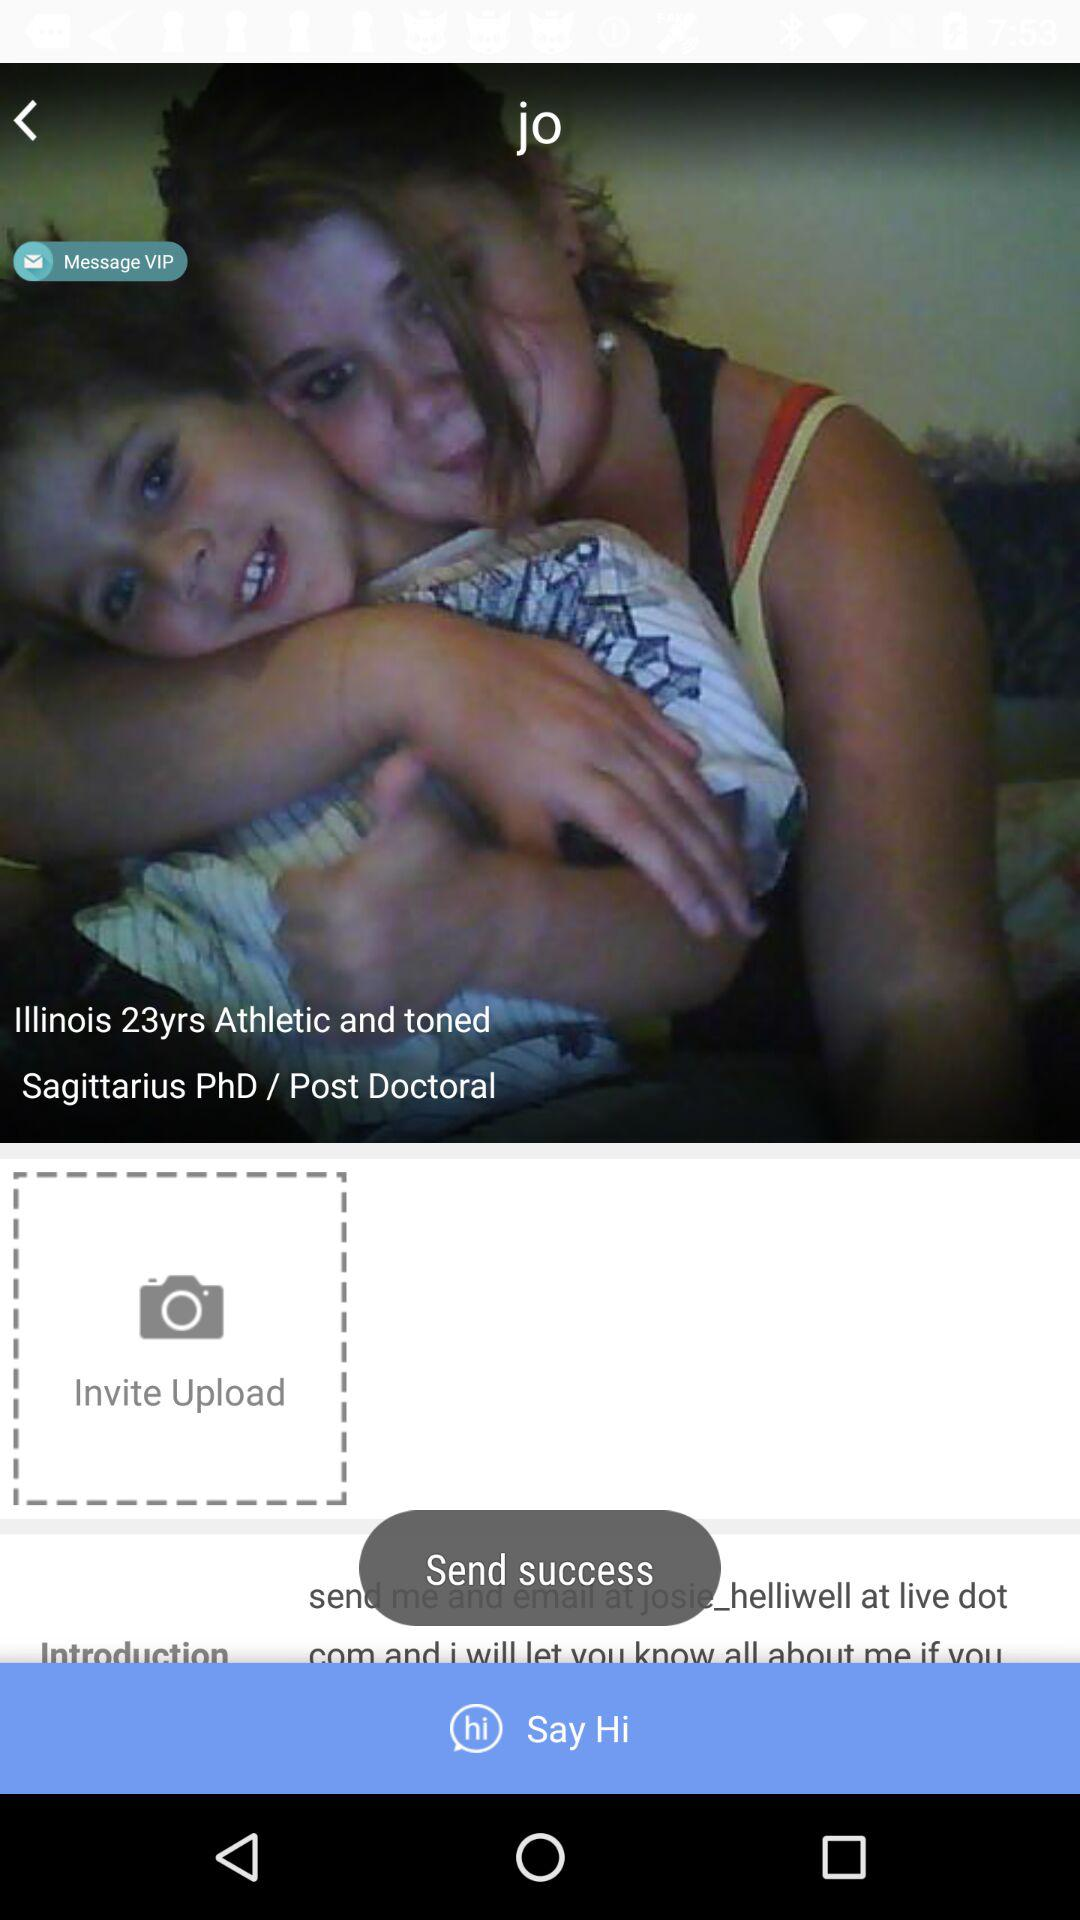Which state is mentioned? The mentioned state is Illinois. 